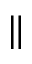Convert formula to latex. <formula><loc_0><loc_0><loc_500><loc_500>\|</formula> 